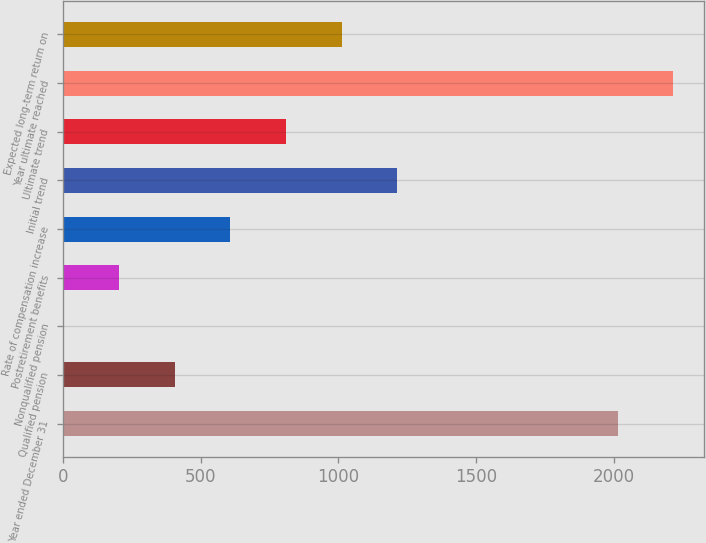Convert chart. <chart><loc_0><loc_0><loc_500><loc_500><bar_chart><fcel>Year ended December 31<fcel>Qualified pension<fcel>Nonqualified pension<fcel>Postretirement benefits<fcel>Rate of compensation increase<fcel>Initial trend<fcel>Ultimate trend<fcel>Year ultimate reached<fcel>Expected long-term return on<nl><fcel>2013<fcel>406.56<fcel>3.45<fcel>205<fcel>608.12<fcel>1212.78<fcel>809.67<fcel>2214.55<fcel>1011.22<nl></chart> 